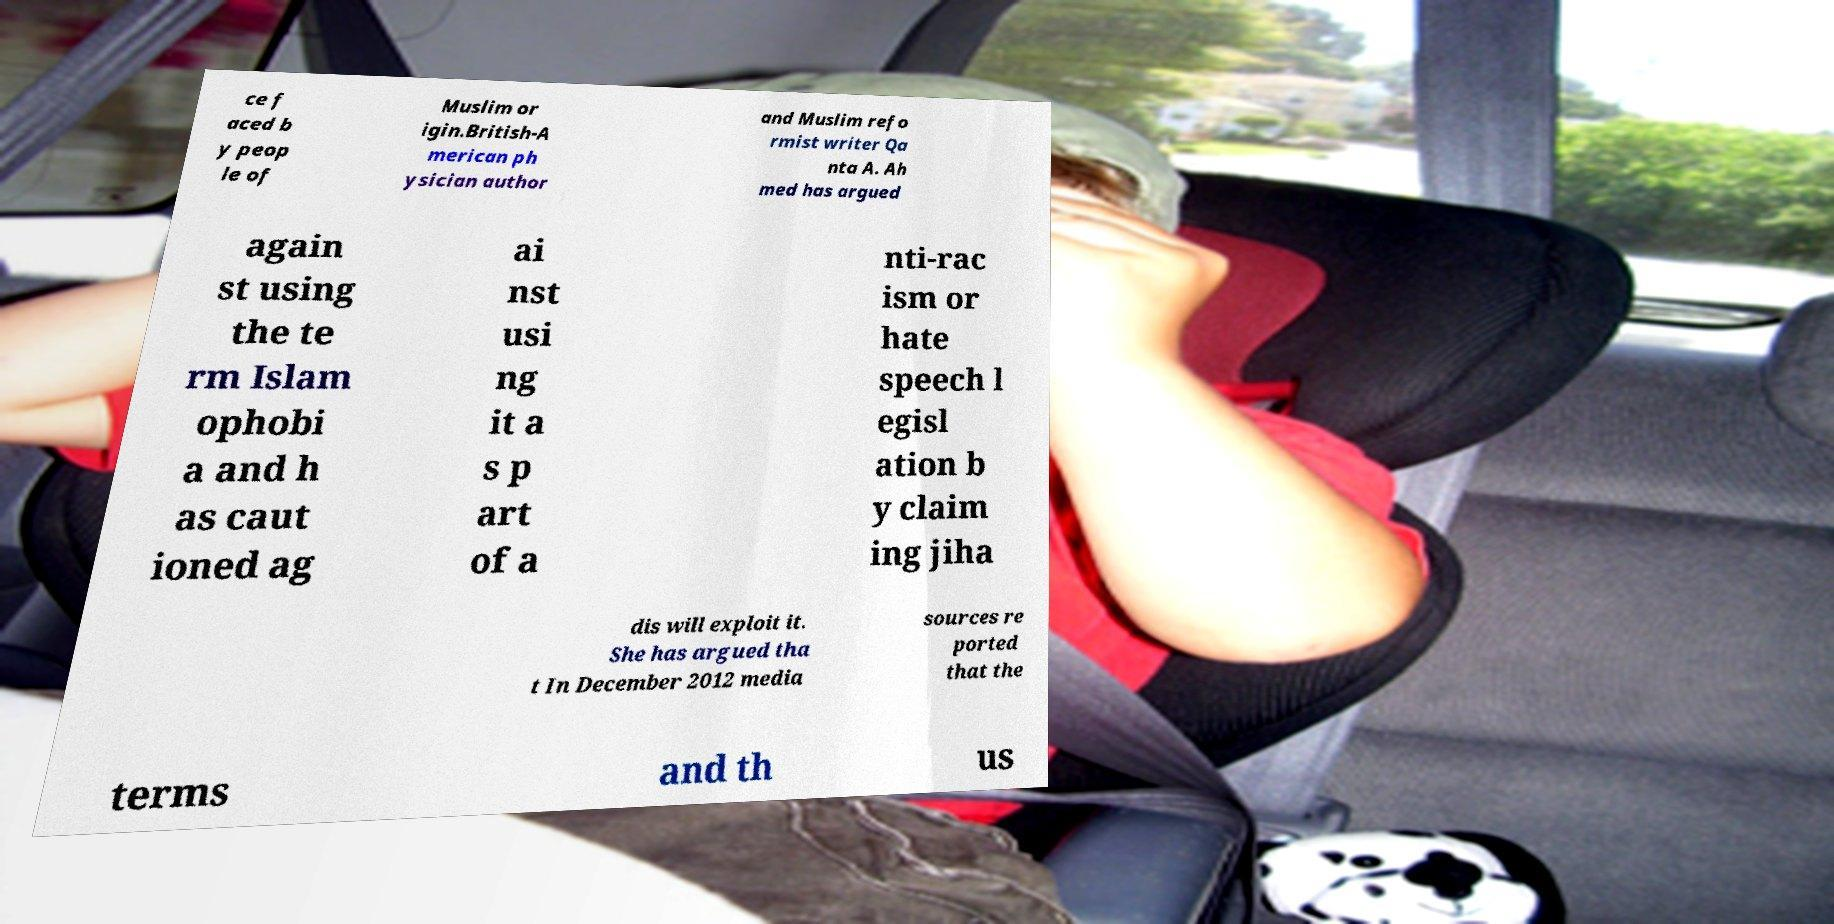Could you extract and type out the text from this image? ce f aced b y peop le of Muslim or igin.British-A merican ph ysician author and Muslim refo rmist writer Qa nta A. Ah med has argued again st using the te rm Islam ophobi a and h as caut ioned ag ai nst usi ng it a s p art of a nti-rac ism or hate speech l egisl ation b y claim ing jiha dis will exploit it. She has argued tha t In December 2012 media sources re ported that the terms and th us 